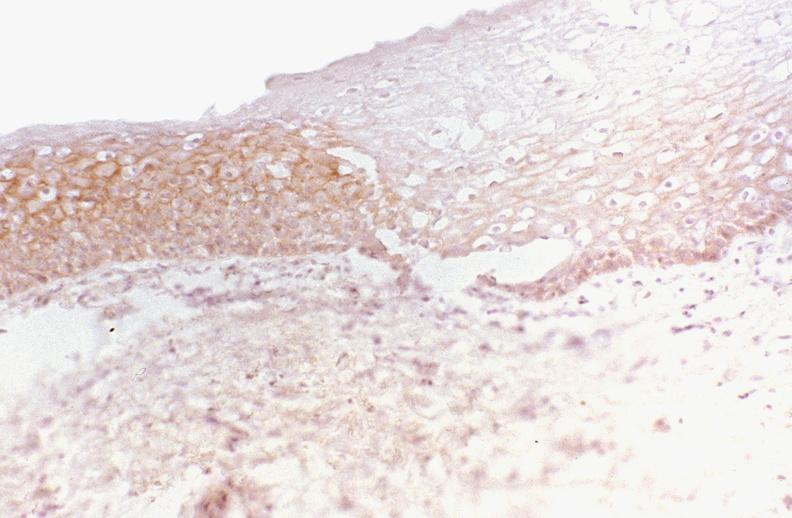does this image show oral dysplasia, neu?
Answer the question using a single word or phrase. Yes 